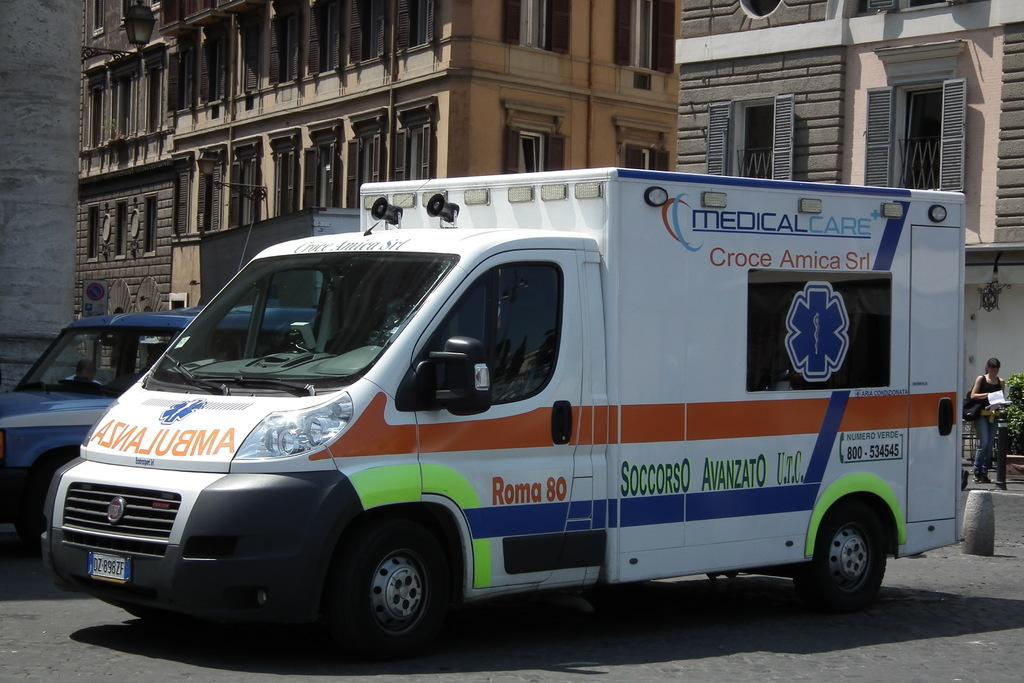What can be seen on the road in the image? There are vehicles on the road in the image. Who is present in the image besides the vehicles? There is a woman in the image. What is the woman holding in her hand? The woman is holding a book. What is the woman carrying in the image? The woman is carrying a bag. What is the position of the woman in the image? The woman is standing. What can be seen in the background of the image? There are buildings with windows in the background of the image. How many pies can be seen on the woman's foot in the image? There are no pies present in the image, and the woman's foot is not visible. What type of chalk is the woman using to write on the buildings in the background? There is no chalk present in the image, and the woman is not writing on any buildings. 